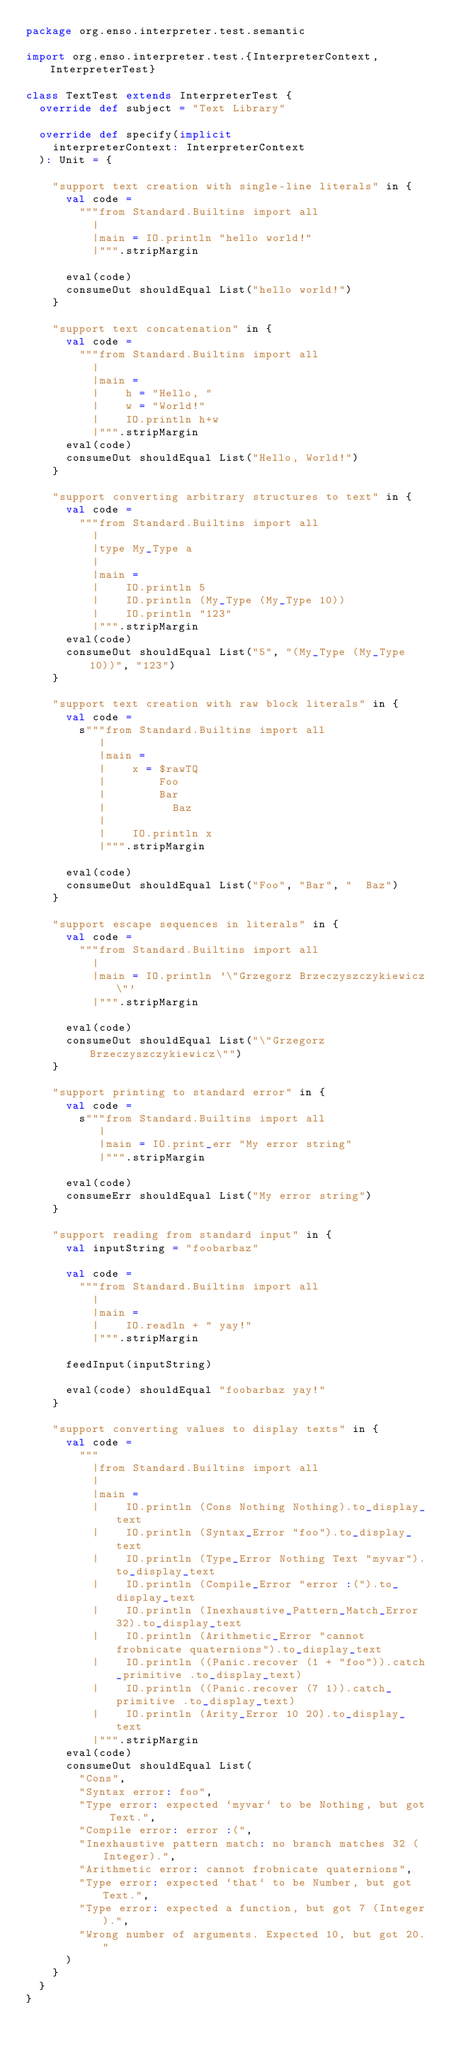Convert code to text. <code><loc_0><loc_0><loc_500><loc_500><_Scala_>package org.enso.interpreter.test.semantic

import org.enso.interpreter.test.{InterpreterContext, InterpreterTest}

class TextTest extends InterpreterTest {
  override def subject = "Text Library"

  override def specify(implicit
    interpreterContext: InterpreterContext
  ): Unit = {

    "support text creation with single-line literals" in {
      val code =
        """from Standard.Builtins import all
          |
          |main = IO.println "hello world!"
          |""".stripMargin

      eval(code)
      consumeOut shouldEqual List("hello world!")
    }

    "support text concatenation" in {
      val code =
        """from Standard.Builtins import all
          |
          |main =
          |    h = "Hello, "
          |    w = "World!"
          |    IO.println h+w
          |""".stripMargin
      eval(code)
      consumeOut shouldEqual List("Hello, World!")
    }

    "support converting arbitrary structures to text" in {
      val code =
        """from Standard.Builtins import all
          |
          |type My_Type a
          |
          |main =
          |    IO.println 5
          |    IO.println (My_Type (My_Type 10))
          |    IO.println "123"
          |""".stripMargin
      eval(code)
      consumeOut shouldEqual List("5", "(My_Type (My_Type 10))", "123")
    }

    "support text creation with raw block literals" in {
      val code =
        s"""from Standard.Builtins import all
           |
           |main =
           |    x = $rawTQ
           |        Foo
           |        Bar
           |          Baz
           |
           |    IO.println x
           |""".stripMargin

      eval(code)
      consumeOut shouldEqual List("Foo", "Bar", "  Baz")
    }

    "support escape sequences in literals" in {
      val code =
        """from Standard.Builtins import all
          |
          |main = IO.println '\"Grzegorz Brzeczyszczykiewicz\"'
          |""".stripMargin

      eval(code)
      consumeOut shouldEqual List("\"Grzegorz Brzeczyszczykiewicz\"")
    }

    "support printing to standard error" in {
      val code =
        s"""from Standard.Builtins import all
           |
           |main = IO.print_err "My error string"
           |""".stripMargin

      eval(code)
      consumeErr shouldEqual List("My error string")
    }

    "support reading from standard input" in {
      val inputString = "foobarbaz"

      val code =
        """from Standard.Builtins import all
          |
          |main =
          |    IO.readln + " yay!"
          |""".stripMargin

      feedInput(inputString)

      eval(code) shouldEqual "foobarbaz yay!"
    }

    "support converting values to display texts" in {
      val code =
        """
          |from Standard.Builtins import all
          |
          |main =
          |    IO.println (Cons Nothing Nothing).to_display_text
          |    IO.println (Syntax_Error "foo").to_display_text
          |    IO.println (Type_Error Nothing Text "myvar").to_display_text
          |    IO.println (Compile_Error "error :(").to_display_text
          |    IO.println (Inexhaustive_Pattern_Match_Error 32).to_display_text
          |    IO.println (Arithmetic_Error "cannot frobnicate quaternions").to_display_text
          |    IO.println ((Panic.recover (1 + "foo")).catch_primitive .to_display_text)
          |    IO.println ((Panic.recover (7 1)).catch_primitive .to_display_text)
          |    IO.println (Arity_Error 10 20).to_display_text
          |""".stripMargin
      eval(code)
      consumeOut shouldEqual List(
        "Cons",
        "Syntax error: foo",
        "Type error: expected `myvar` to be Nothing, but got Text.",
        "Compile error: error :(",
        "Inexhaustive pattern match: no branch matches 32 (Integer).",
        "Arithmetic error: cannot frobnicate quaternions",
        "Type error: expected `that` to be Number, but got Text.",
        "Type error: expected a function, but got 7 (Integer).",
        "Wrong number of arguments. Expected 10, but got 20."
      )
    }
  }
}
</code> 